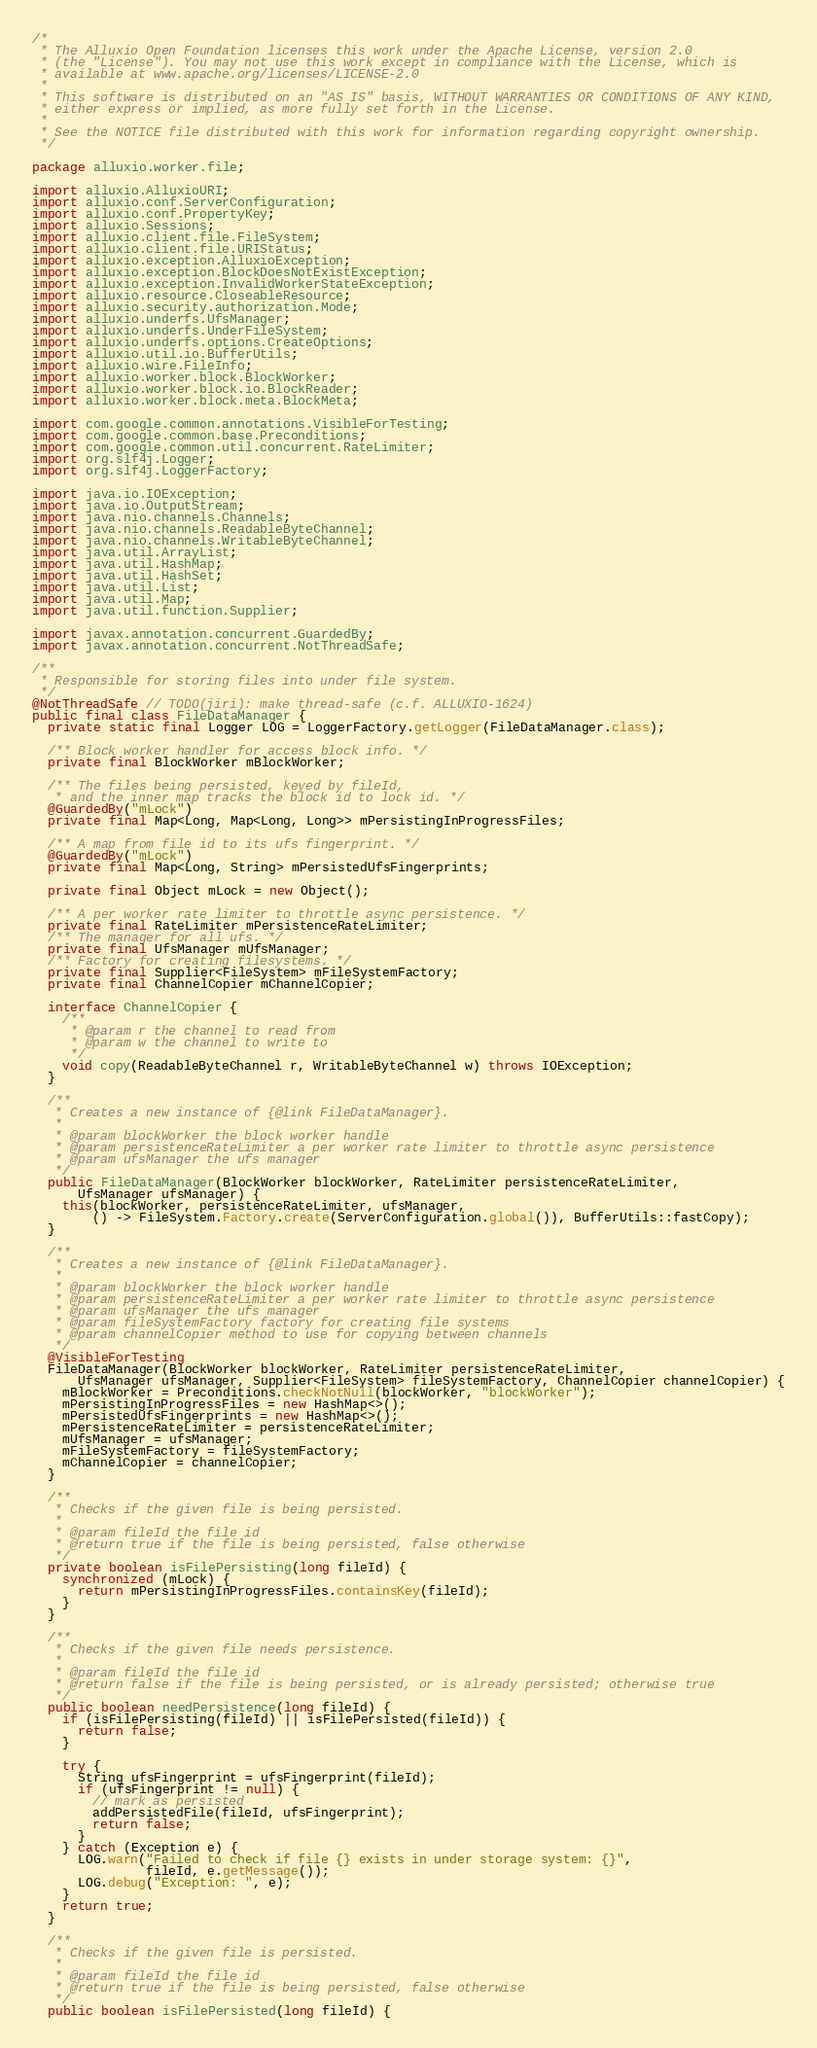Convert code to text. <code><loc_0><loc_0><loc_500><loc_500><_Java_>/*
 * The Alluxio Open Foundation licenses this work under the Apache License, version 2.0
 * (the "License"). You may not use this work except in compliance with the License, which is
 * available at www.apache.org/licenses/LICENSE-2.0
 *
 * This software is distributed on an "AS IS" basis, WITHOUT WARRANTIES OR CONDITIONS OF ANY KIND,
 * either express or implied, as more fully set forth in the License.
 *
 * See the NOTICE file distributed with this work for information regarding copyright ownership.
 */

package alluxio.worker.file;

import alluxio.AlluxioURI;
import alluxio.conf.ServerConfiguration;
import alluxio.conf.PropertyKey;
import alluxio.Sessions;
import alluxio.client.file.FileSystem;
import alluxio.client.file.URIStatus;
import alluxio.exception.AlluxioException;
import alluxio.exception.BlockDoesNotExistException;
import alluxio.exception.InvalidWorkerStateException;
import alluxio.resource.CloseableResource;
import alluxio.security.authorization.Mode;
import alluxio.underfs.UfsManager;
import alluxio.underfs.UnderFileSystem;
import alluxio.underfs.options.CreateOptions;
import alluxio.util.io.BufferUtils;
import alluxio.wire.FileInfo;
import alluxio.worker.block.BlockWorker;
import alluxio.worker.block.io.BlockReader;
import alluxio.worker.block.meta.BlockMeta;

import com.google.common.annotations.VisibleForTesting;
import com.google.common.base.Preconditions;
import com.google.common.util.concurrent.RateLimiter;
import org.slf4j.Logger;
import org.slf4j.LoggerFactory;

import java.io.IOException;
import java.io.OutputStream;
import java.nio.channels.Channels;
import java.nio.channels.ReadableByteChannel;
import java.nio.channels.WritableByteChannel;
import java.util.ArrayList;
import java.util.HashMap;
import java.util.HashSet;
import java.util.List;
import java.util.Map;
import java.util.function.Supplier;

import javax.annotation.concurrent.GuardedBy;
import javax.annotation.concurrent.NotThreadSafe;

/**
 * Responsible for storing files into under file system.
 */
@NotThreadSafe // TODO(jiri): make thread-safe (c.f. ALLUXIO-1624)
public final class FileDataManager {
  private static final Logger LOG = LoggerFactory.getLogger(FileDataManager.class);

  /** Block worker handler for access block info. */
  private final BlockWorker mBlockWorker;

  /** The files being persisted, keyed by fileId,
   * and the inner map tracks the block id to lock id. */
  @GuardedBy("mLock")
  private final Map<Long, Map<Long, Long>> mPersistingInProgressFiles;

  /** A map from file id to its ufs fingerprint. */
  @GuardedBy("mLock")
  private final Map<Long, String> mPersistedUfsFingerprints;

  private final Object mLock = new Object();

  /** A per worker rate limiter to throttle async persistence. */
  private final RateLimiter mPersistenceRateLimiter;
  /** The manager for all ufs. */
  private final UfsManager mUfsManager;
  /** Factory for creating filesystems. */
  private final Supplier<FileSystem> mFileSystemFactory;
  private final ChannelCopier mChannelCopier;

  interface ChannelCopier {
    /**
     * @param r the channel to read from
     * @param w the channel to write to
     */
    void copy(ReadableByteChannel r, WritableByteChannel w) throws IOException;
  }

  /**
   * Creates a new instance of {@link FileDataManager}.
   *
   * @param blockWorker the block worker handle
   * @param persistenceRateLimiter a per worker rate limiter to throttle async persistence
   * @param ufsManager the ufs manager
   */
  public FileDataManager(BlockWorker blockWorker, RateLimiter persistenceRateLimiter,
      UfsManager ufsManager) {
    this(blockWorker, persistenceRateLimiter, ufsManager,
        () -> FileSystem.Factory.create(ServerConfiguration.global()), BufferUtils::fastCopy);
  }

  /**
   * Creates a new instance of {@link FileDataManager}.
   *
   * @param blockWorker the block worker handle
   * @param persistenceRateLimiter a per worker rate limiter to throttle async persistence
   * @param ufsManager the ufs manager
   * @param fileSystemFactory factory for creating file systems
   * @param channelCopier method to use for copying between channels
   */
  @VisibleForTesting
  FileDataManager(BlockWorker blockWorker, RateLimiter persistenceRateLimiter,
      UfsManager ufsManager, Supplier<FileSystem> fileSystemFactory, ChannelCopier channelCopier) {
    mBlockWorker = Preconditions.checkNotNull(blockWorker, "blockWorker");
    mPersistingInProgressFiles = new HashMap<>();
    mPersistedUfsFingerprints = new HashMap<>();
    mPersistenceRateLimiter = persistenceRateLimiter;
    mUfsManager = ufsManager;
    mFileSystemFactory = fileSystemFactory;
    mChannelCopier = channelCopier;
  }

  /**
   * Checks if the given file is being persisted.
   *
   * @param fileId the file id
   * @return true if the file is being persisted, false otherwise
   */
  private boolean isFilePersisting(long fileId) {
    synchronized (mLock) {
      return mPersistingInProgressFiles.containsKey(fileId);
    }
  }

  /**
   * Checks if the given file needs persistence.
   *
   * @param fileId the file id
   * @return false if the file is being persisted, or is already persisted; otherwise true
   */
  public boolean needPersistence(long fileId) {
    if (isFilePersisting(fileId) || isFilePersisted(fileId)) {
      return false;
    }

    try {
      String ufsFingerprint = ufsFingerprint(fileId);
      if (ufsFingerprint != null) {
        // mark as persisted
        addPersistedFile(fileId, ufsFingerprint);
        return false;
      }
    } catch (Exception e) {
      LOG.warn("Failed to check if file {} exists in under storage system: {}",
               fileId, e.getMessage());
      LOG.debug("Exception: ", e);
    }
    return true;
  }

  /**
   * Checks if the given file is persisted.
   *
   * @param fileId the file id
   * @return true if the file is being persisted, false otherwise
   */
  public boolean isFilePersisted(long fileId) {</code> 